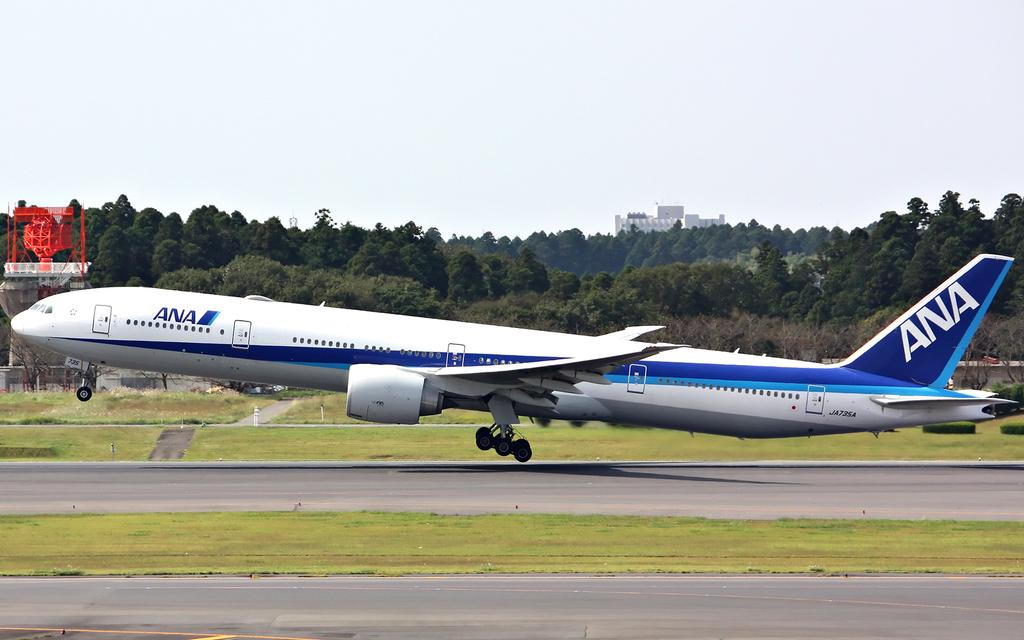<image>
Share a concise interpretation of the image provided. A blue and white passenger plane with the letters ANA. 